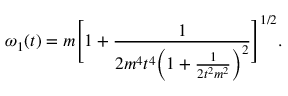<formula> <loc_0><loc_0><loc_500><loc_500>\omega _ { 1 } ( t ) = m \left [ 1 + \frac { 1 } { 2 m ^ { 4 } t ^ { 4 } \left ( 1 + \frac { 1 } { 2 t ^ { 2 } m ^ { 2 } } \right ) ^ { 2 } } \right ] ^ { 1 / 2 } .</formula> 